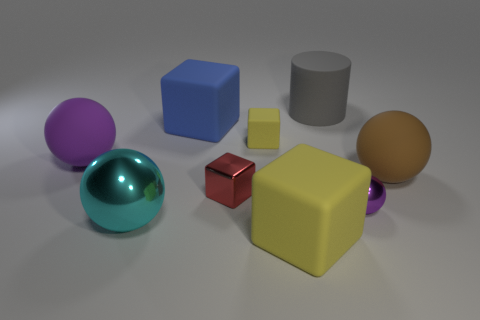Subtract all matte blocks. How many blocks are left? 1 Add 9 big cylinders. How many big cylinders exist? 10 Subtract all brown balls. How many balls are left? 3 Subtract 1 purple spheres. How many objects are left? 8 Subtract all cylinders. How many objects are left? 8 Subtract 4 spheres. How many spheres are left? 0 Subtract all red balls. Subtract all red blocks. How many balls are left? 4 Subtract all green spheres. How many red blocks are left? 1 Subtract all matte things. Subtract all large rubber cylinders. How many objects are left? 2 Add 3 brown objects. How many brown objects are left? 4 